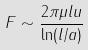<formula> <loc_0><loc_0><loc_500><loc_500>F \sim \frac { 2 \pi \mu l u } { \ln ( l / a ) }</formula> 